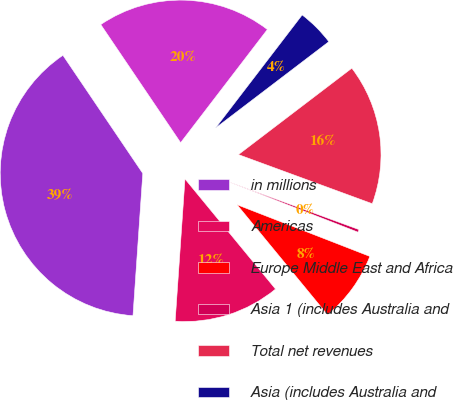Convert chart. <chart><loc_0><loc_0><loc_500><loc_500><pie_chart><fcel>in millions<fcel>Americas<fcel>Europe Middle East and Africa<fcel>Asia 1 (includes Australia and<fcel>Total net revenues<fcel>Asia (includes Australia and<fcel>Subtotal<nl><fcel>39.44%<fcel>12.05%<fcel>8.14%<fcel>0.31%<fcel>15.96%<fcel>4.23%<fcel>19.87%<nl></chart> 